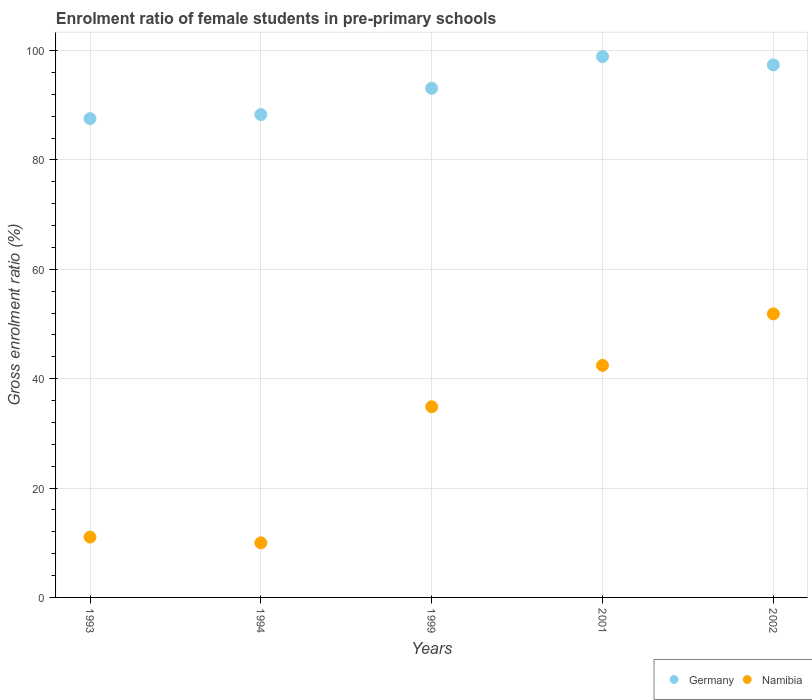How many different coloured dotlines are there?
Provide a short and direct response. 2. Is the number of dotlines equal to the number of legend labels?
Your answer should be compact. Yes. What is the enrolment ratio of female students in pre-primary schools in Germany in 2001?
Ensure brevity in your answer.  98.89. Across all years, what is the maximum enrolment ratio of female students in pre-primary schools in Germany?
Your response must be concise. 98.89. Across all years, what is the minimum enrolment ratio of female students in pre-primary schools in Germany?
Keep it short and to the point. 87.54. In which year was the enrolment ratio of female students in pre-primary schools in Namibia maximum?
Ensure brevity in your answer.  2002. What is the total enrolment ratio of female students in pre-primary schools in Germany in the graph?
Make the answer very short. 465.18. What is the difference between the enrolment ratio of female students in pre-primary schools in Germany in 2001 and that in 2002?
Make the answer very short. 1.53. What is the difference between the enrolment ratio of female students in pre-primary schools in Namibia in 1993 and the enrolment ratio of female students in pre-primary schools in Germany in 1999?
Make the answer very short. -82.06. What is the average enrolment ratio of female students in pre-primary schools in Germany per year?
Offer a very short reply. 93.04. In the year 1994, what is the difference between the enrolment ratio of female students in pre-primary schools in Namibia and enrolment ratio of female students in pre-primary schools in Germany?
Give a very brief answer. -78.3. In how many years, is the enrolment ratio of female students in pre-primary schools in Germany greater than 28 %?
Give a very brief answer. 5. What is the ratio of the enrolment ratio of female students in pre-primary schools in Germany in 1993 to that in 1999?
Provide a succinct answer. 0.94. What is the difference between the highest and the second highest enrolment ratio of female students in pre-primary schools in Namibia?
Provide a succinct answer. 9.41. What is the difference between the highest and the lowest enrolment ratio of female students in pre-primary schools in Namibia?
Make the answer very short. 41.86. Is the sum of the enrolment ratio of female students in pre-primary schools in Germany in 1999 and 2002 greater than the maximum enrolment ratio of female students in pre-primary schools in Namibia across all years?
Offer a very short reply. Yes. Does the enrolment ratio of female students in pre-primary schools in Germany monotonically increase over the years?
Ensure brevity in your answer.  No. How many dotlines are there?
Ensure brevity in your answer.  2. Are the values on the major ticks of Y-axis written in scientific E-notation?
Give a very brief answer. No. Does the graph contain any zero values?
Make the answer very short. No. Where does the legend appear in the graph?
Give a very brief answer. Bottom right. How many legend labels are there?
Your response must be concise. 2. What is the title of the graph?
Ensure brevity in your answer.  Enrolment ratio of female students in pre-primary schools. Does "Panama" appear as one of the legend labels in the graph?
Provide a succinct answer. No. What is the Gross enrolment ratio (%) in Germany in 1993?
Make the answer very short. 87.54. What is the Gross enrolment ratio (%) of Namibia in 1993?
Offer a very short reply. 11.03. What is the Gross enrolment ratio (%) of Germany in 1994?
Offer a very short reply. 88.28. What is the Gross enrolment ratio (%) of Namibia in 1994?
Provide a succinct answer. 9.98. What is the Gross enrolment ratio (%) of Germany in 1999?
Keep it short and to the point. 93.09. What is the Gross enrolment ratio (%) of Namibia in 1999?
Ensure brevity in your answer.  34.86. What is the Gross enrolment ratio (%) of Germany in 2001?
Offer a terse response. 98.89. What is the Gross enrolment ratio (%) in Namibia in 2001?
Make the answer very short. 42.43. What is the Gross enrolment ratio (%) in Germany in 2002?
Provide a succinct answer. 97.37. What is the Gross enrolment ratio (%) of Namibia in 2002?
Your answer should be very brief. 51.84. Across all years, what is the maximum Gross enrolment ratio (%) of Germany?
Give a very brief answer. 98.89. Across all years, what is the maximum Gross enrolment ratio (%) in Namibia?
Offer a terse response. 51.84. Across all years, what is the minimum Gross enrolment ratio (%) in Germany?
Make the answer very short. 87.54. Across all years, what is the minimum Gross enrolment ratio (%) in Namibia?
Give a very brief answer. 9.98. What is the total Gross enrolment ratio (%) of Germany in the graph?
Make the answer very short. 465.18. What is the total Gross enrolment ratio (%) of Namibia in the graph?
Your response must be concise. 150.15. What is the difference between the Gross enrolment ratio (%) of Germany in 1993 and that in 1994?
Provide a succinct answer. -0.74. What is the difference between the Gross enrolment ratio (%) of Namibia in 1993 and that in 1994?
Provide a short and direct response. 1.05. What is the difference between the Gross enrolment ratio (%) in Germany in 1993 and that in 1999?
Provide a succinct answer. -5.55. What is the difference between the Gross enrolment ratio (%) in Namibia in 1993 and that in 1999?
Give a very brief answer. -23.82. What is the difference between the Gross enrolment ratio (%) of Germany in 1993 and that in 2001?
Your answer should be compact. -11.35. What is the difference between the Gross enrolment ratio (%) of Namibia in 1993 and that in 2001?
Your answer should be compact. -31.4. What is the difference between the Gross enrolment ratio (%) of Germany in 1993 and that in 2002?
Make the answer very short. -9.82. What is the difference between the Gross enrolment ratio (%) in Namibia in 1993 and that in 2002?
Make the answer very short. -40.81. What is the difference between the Gross enrolment ratio (%) of Germany in 1994 and that in 1999?
Ensure brevity in your answer.  -4.81. What is the difference between the Gross enrolment ratio (%) of Namibia in 1994 and that in 1999?
Keep it short and to the point. -24.87. What is the difference between the Gross enrolment ratio (%) in Germany in 1994 and that in 2001?
Your answer should be compact. -10.61. What is the difference between the Gross enrolment ratio (%) of Namibia in 1994 and that in 2001?
Provide a short and direct response. -32.44. What is the difference between the Gross enrolment ratio (%) in Germany in 1994 and that in 2002?
Offer a very short reply. -9.09. What is the difference between the Gross enrolment ratio (%) of Namibia in 1994 and that in 2002?
Your answer should be very brief. -41.86. What is the difference between the Gross enrolment ratio (%) of Germany in 1999 and that in 2001?
Offer a very short reply. -5.8. What is the difference between the Gross enrolment ratio (%) in Namibia in 1999 and that in 2001?
Ensure brevity in your answer.  -7.57. What is the difference between the Gross enrolment ratio (%) in Germany in 1999 and that in 2002?
Offer a terse response. -4.27. What is the difference between the Gross enrolment ratio (%) in Namibia in 1999 and that in 2002?
Your response must be concise. -16.98. What is the difference between the Gross enrolment ratio (%) of Germany in 2001 and that in 2002?
Your answer should be compact. 1.53. What is the difference between the Gross enrolment ratio (%) of Namibia in 2001 and that in 2002?
Give a very brief answer. -9.41. What is the difference between the Gross enrolment ratio (%) in Germany in 1993 and the Gross enrolment ratio (%) in Namibia in 1994?
Your answer should be compact. 77.56. What is the difference between the Gross enrolment ratio (%) of Germany in 1993 and the Gross enrolment ratio (%) of Namibia in 1999?
Provide a succinct answer. 52.68. What is the difference between the Gross enrolment ratio (%) of Germany in 1993 and the Gross enrolment ratio (%) of Namibia in 2001?
Ensure brevity in your answer.  45.11. What is the difference between the Gross enrolment ratio (%) of Germany in 1993 and the Gross enrolment ratio (%) of Namibia in 2002?
Your response must be concise. 35.7. What is the difference between the Gross enrolment ratio (%) in Germany in 1994 and the Gross enrolment ratio (%) in Namibia in 1999?
Offer a terse response. 53.42. What is the difference between the Gross enrolment ratio (%) in Germany in 1994 and the Gross enrolment ratio (%) in Namibia in 2001?
Make the answer very short. 45.85. What is the difference between the Gross enrolment ratio (%) of Germany in 1994 and the Gross enrolment ratio (%) of Namibia in 2002?
Make the answer very short. 36.44. What is the difference between the Gross enrolment ratio (%) in Germany in 1999 and the Gross enrolment ratio (%) in Namibia in 2001?
Provide a succinct answer. 50.66. What is the difference between the Gross enrolment ratio (%) of Germany in 1999 and the Gross enrolment ratio (%) of Namibia in 2002?
Your answer should be compact. 41.25. What is the difference between the Gross enrolment ratio (%) in Germany in 2001 and the Gross enrolment ratio (%) in Namibia in 2002?
Your response must be concise. 47.05. What is the average Gross enrolment ratio (%) in Germany per year?
Your response must be concise. 93.04. What is the average Gross enrolment ratio (%) in Namibia per year?
Offer a terse response. 30.03. In the year 1993, what is the difference between the Gross enrolment ratio (%) in Germany and Gross enrolment ratio (%) in Namibia?
Ensure brevity in your answer.  76.51. In the year 1994, what is the difference between the Gross enrolment ratio (%) in Germany and Gross enrolment ratio (%) in Namibia?
Your response must be concise. 78.3. In the year 1999, what is the difference between the Gross enrolment ratio (%) in Germany and Gross enrolment ratio (%) in Namibia?
Your answer should be compact. 58.24. In the year 2001, what is the difference between the Gross enrolment ratio (%) of Germany and Gross enrolment ratio (%) of Namibia?
Your answer should be compact. 56.46. In the year 2002, what is the difference between the Gross enrolment ratio (%) in Germany and Gross enrolment ratio (%) in Namibia?
Offer a very short reply. 45.52. What is the ratio of the Gross enrolment ratio (%) in Namibia in 1993 to that in 1994?
Provide a succinct answer. 1.11. What is the ratio of the Gross enrolment ratio (%) of Germany in 1993 to that in 1999?
Your answer should be compact. 0.94. What is the ratio of the Gross enrolment ratio (%) in Namibia in 1993 to that in 1999?
Provide a succinct answer. 0.32. What is the ratio of the Gross enrolment ratio (%) in Germany in 1993 to that in 2001?
Your response must be concise. 0.89. What is the ratio of the Gross enrolment ratio (%) in Namibia in 1993 to that in 2001?
Offer a very short reply. 0.26. What is the ratio of the Gross enrolment ratio (%) in Germany in 1993 to that in 2002?
Offer a very short reply. 0.9. What is the ratio of the Gross enrolment ratio (%) in Namibia in 1993 to that in 2002?
Ensure brevity in your answer.  0.21. What is the ratio of the Gross enrolment ratio (%) in Germany in 1994 to that in 1999?
Your answer should be very brief. 0.95. What is the ratio of the Gross enrolment ratio (%) in Namibia in 1994 to that in 1999?
Make the answer very short. 0.29. What is the ratio of the Gross enrolment ratio (%) in Germany in 1994 to that in 2001?
Your response must be concise. 0.89. What is the ratio of the Gross enrolment ratio (%) in Namibia in 1994 to that in 2001?
Offer a terse response. 0.24. What is the ratio of the Gross enrolment ratio (%) of Germany in 1994 to that in 2002?
Your response must be concise. 0.91. What is the ratio of the Gross enrolment ratio (%) of Namibia in 1994 to that in 2002?
Keep it short and to the point. 0.19. What is the ratio of the Gross enrolment ratio (%) in Germany in 1999 to that in 2001?
Keep it short and to the point. 0.94. What is the ratio of the Gross enrolment ratio (%) of Namibia in 1999 to that in 2001?
Keep it short and to the point. 0.82. What is the ratio of the Gross enrolment ratio (%) of Germany in 1999 to that in 2002?
Provide a short and direct response. 0.96. What is the ratio of the Gross enrolment ratio (%) in Namibia in 1999 to that in 2002?
Ensure brevity in your answer.  0.67. What is the ratio of the Gross enrolment ratio (%) of Germany in 2001 to that in 2002?
Provide a short and direct response. 1.02. What is the ratio of the Gross enrolment ratio (%) of Namibia in 2001 to that in 2002?
Offer a very short reply. 0.82. What is the difference between the highest and the second highest Gross enrolment ratio (%) in Germany?
Offer a terse response. 1.53. What is the difference between the highest and the second highest Gross enrolment ratio (%) in Namibia?
Your answer should be compact. 9.41. What is the difference between the highest and the lowest Gross enrolment ratio (%) in Germany?
Offer a terse response. 11.35. What is the difference between the highest and the lowest Gross enrolment ratio (%) in Namibia?
Offer a terse response. 41.86. 